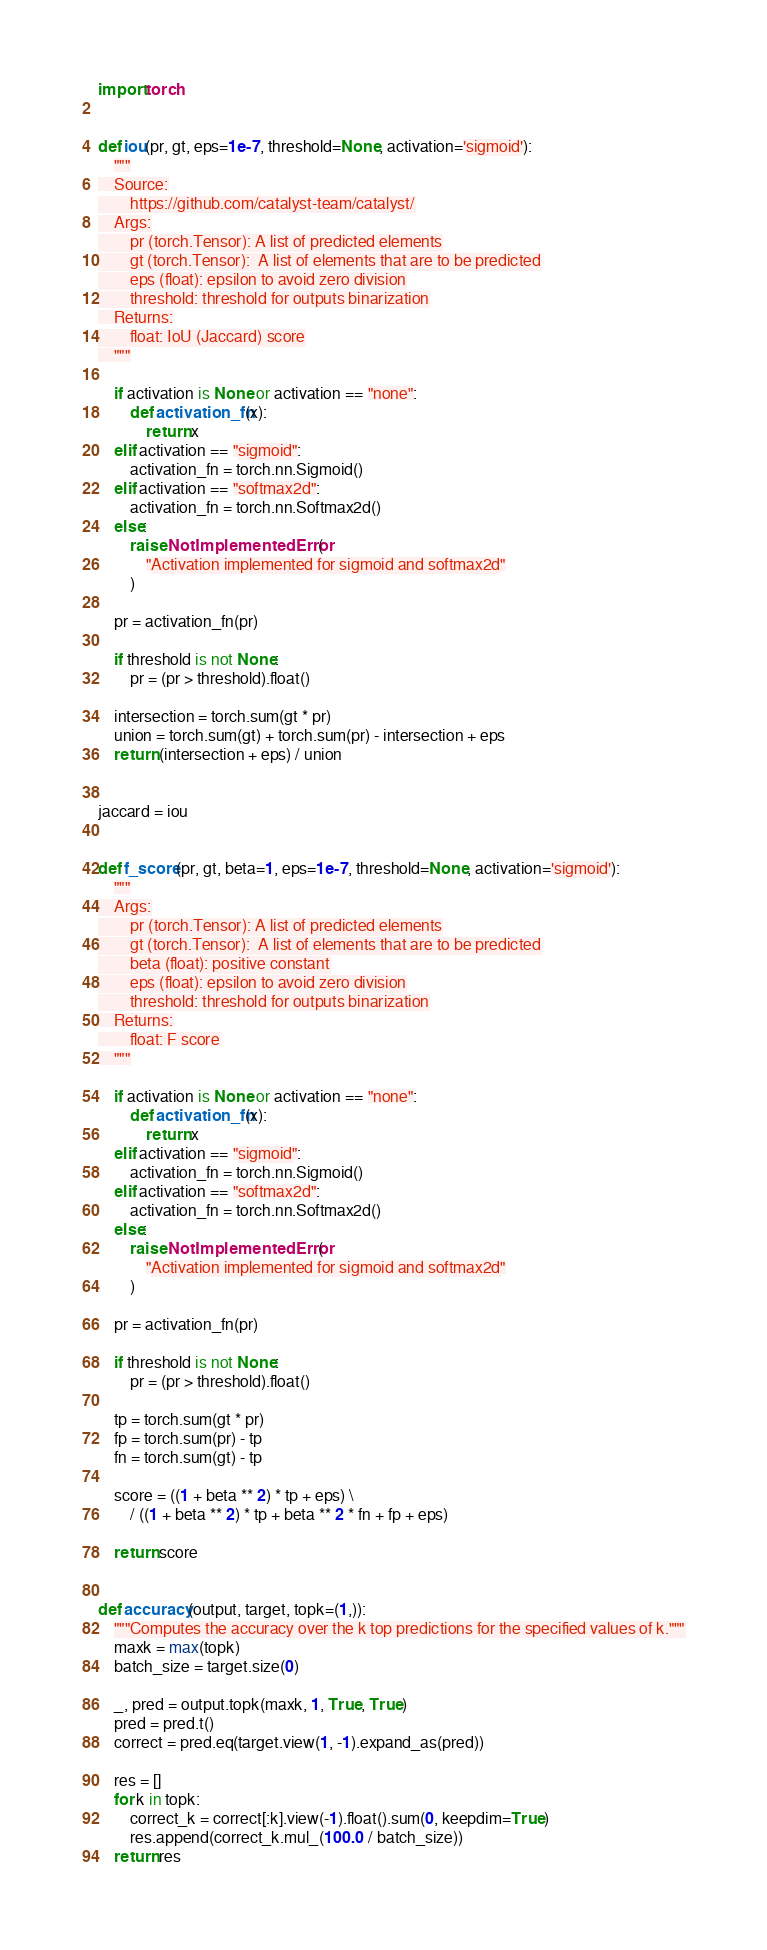<code> <loc_0><loc_0><loc_500><loc_500><_Python_>import torch


def iou(pr, gt, eps=1e-7, threshold=None, activation='sigmoid'):
    """
    Source:
        https://github.com/catalyst-team/catalyst/
    Args:
        pr (torch.Tensor): A list of predicted elements
        gt (torch.Tensor):  A list of elements that are to be predicted
        eps (float): epsilon to avoid zero division
        threshold: threshold for outputs binarization
    Returns:
        float: IoU (Jaccard) score
    """

    if activation is None or activation == "none":
        def activation_fn(x):
            return x
    elif activation == "sigmoid":
        activation_fn = torch.nn.Sigmoid()
    elif activation == "softmax2d":
        activation_fn = torch.nn.Softmax2d()
    else:
        raise NotImplementedError(
            "Activation implemented for sigmoid and softmax2d"
        )

    pr = activation_fn(pr)

    if threshold is not None:
        pr = (pr > threshold).float()

    intersection = torch.sum(gt * pr)
    union = torch.sum(gt) + torch.sum(pr) - intersection + eps
    return (intersection + eps) / union


jaccard = iou


def f_score(pr, gt, beta=1, eps=1e-7, threshold=None, activation='sigmoid'):
    """
    Args:
        pr (torch.Tensor): A list of predicted elements
        gt (torch.Tensor):  A list of elements that are to be predicted
        beta (float): positive constant
        eps (float): epsilon to avoid zero division
        threshold: threshold for outputs binarization
    Returns:
        float: F score
    """

    if activation is None or activation == "none":
        def activation_fn(x):
            return x
    elif activation == "sigmoid":
        activation_fn = torch.nn.Sigmoid()
    elif activation == "softmax2d":
        activation_fn = torch.nn.Softmax2d()
    else:
        raise NotImplementedError(
            "Activation implemented for sigmoid and softmax2d"
        )

    pr = activation_fn(pr)

    if threshold is not None:
        pr = (pr > threshold).float()

    tp = torch.sum(gt * pr)
    fp = torch.sum(pr) - tp
    fn = torch.sum(gt) - tp

    score = ((1 + beta ** 2) * tp + eps) \
        / ((1 + beta ** 2) * tp + beta ** 2 * fn + fp + eps)

    return score


def accuracy(output, target, topk=(1,)):
    """Computes the accuracy over the k top predictions for the specified values of k."""
    maxk = max(topk)
    batch_size = target.size(0)

    _, pred = output.topk(maxk, 1, True, True)
    pred = pred.t()
    correct = pred.eq(target.view(1, -1).expand_as(pred))

    res = []
    for k in topk:
        correct_k = correct[:k].view(-1).float().sum(0, keepdim=True)
        res.append(correct_k.mul_(100.0 / batch_size))
    return res
</code> 